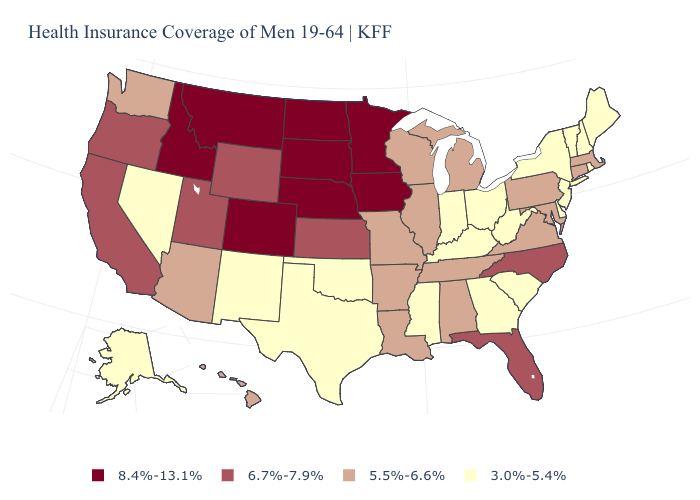Among the states that border North Carolina , which have the lowest value?
Give a very brief answer. Georgia, South Carolina. Name the states that have a value in the range 8.4%-13.1%?
Short answer required. Colorado, Idaho, Iowa, Minnesota, Montana, Nebraska, North Dakota, South Dakota. Name the states that have a value in the range 5.5%-6.6%?
Concise answer only. Alabama, Arizona, Arkansas, Connecticut, Hawaii, Illinois, Louisiana, Maryland, Massachusetts, Michigan, Missouri, Pennsylvania, Tennessee, Virginia, Washington, Wisconsin. Does Minnesota have the highest value in the USA?
Be succinct. Yes. What is the value of Maryland?
Keep it brief. 5.5%-6.6%. How many symbols are there in the legend?
Give a very brief answer. 4. What is the value of Kentucky?
Short answer required. 3.0%-5.4%. Name the states that have a value in the range 6.7%-7.9%?
Give a very brief answer. California, Florida, Kansas, North Carolina, Oregon, Utah, Wyoming. Name the states that have a value in the range 6.7%-7.9%?
Be succinct. California, Florida, Kansas, North Carolina, Oregon, Utah, Wyoming. What is the value of Hawaii?
Be succinct. 5.5%-6.6%. Among the states that border Minnesota , does Iowa have the lowest value?
Be succinct. No. Name the states that have a value in the range 5.5%-6.6%?
Be succinct. Alabama, Arizona, Arkansas, Connecticut, Hawaii, Illinois, Louisiana, Maryland, Massachusetts, Michigan, Missouri, Pennsylvania, Tennessee, Virginia, Washington, Wisconsin. Among the states that border Minnesota , does Wisconsin have the highest value?
Answer briefly. No. Does the map have missing data?
Answer briefly. No. What is the value of Indiana?
Give a very brief answer. 3.0%-5.4%. 